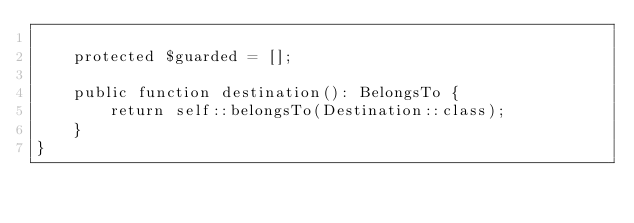<code> <loc_0><loc_0><loc_500><loc_500><_PHP_>
    protected $guarded = [];

    public function destination(): BelongsTo {
        return self::belongsTo(Destination::class);
    }
}
</code> 